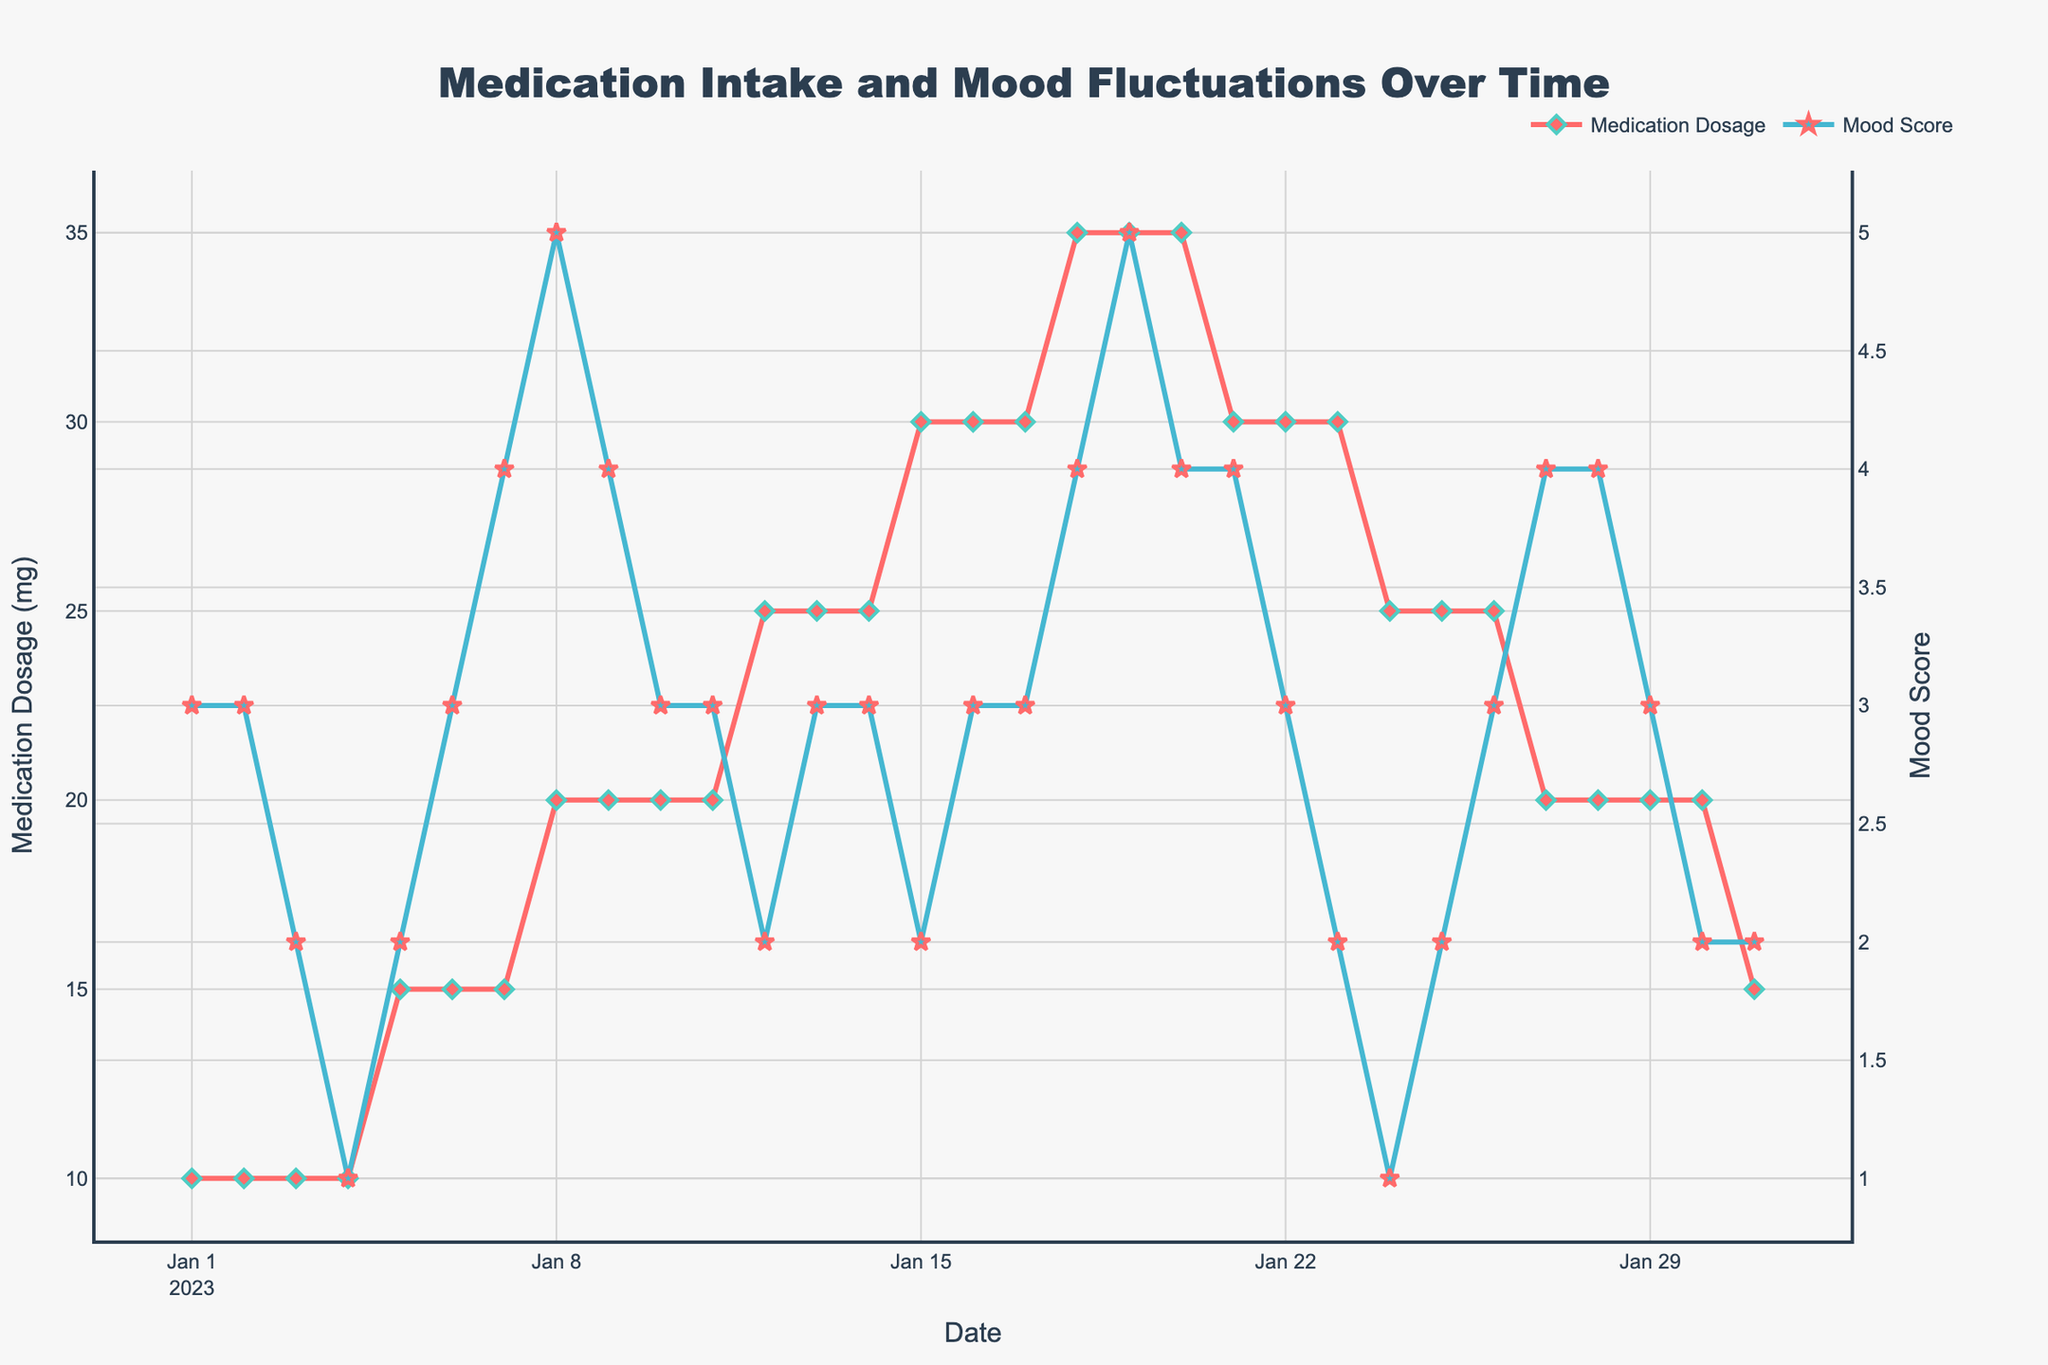what is the title of the figure? The title is displayed at the top center of the figure in a large font. It summarizes the content of the figure, indicating what the visualizations represent.
Answer: Medication Intake and Mood Fluctuations Over Time how many data points are there in total? Each date represents one data point, visible as markers on the plot. Both lines have data points marked by unique markers (diamonds and stars).
Answer: 31 what is the range of the mood score throughout the period? The Mood Score Y-axis shows values starting from the lowest point to the highest point during the plot period. By looking at the Mood Score trend line and markers, the minimum and maximum scores can be identified.
Answer: 1 to 5 what is the relationship between medication dosage and mood score on January 8th? January 8th marks a point on both Medication Dosage and Mood Score lines. By locating January 8th on the X-axis, you can observe the values on both Y-axes.
Answer: Medication Dosage: 20 mg, Mood Score: 5 what happened to the mood score when the medication dosage increased to 25 mg for the first time? Look at the date when the dosage first increased to 25 mg, check the Mood Score value before and after this date by following the mood score markers.
Answer: Dropped from 3 to 2 compare the trend of medication dosage and mood score from January 15th to 21st Observe the plot between January 15th and 21st. Track the changes in both Medication Dosage (left Y-axis) and Mood Score (right Y-axis) by noting the slopes and directions of the lines.
Answer: Medication Dosage increases to 35 mg and then drops to 30 mg. Mood Score rises from 2 to 4, then drops slightly what is the average medication dosage from Jan 10 to Jan 20? List the Medication Dosage values between Jan 10 and Jan 20, then calculate their mean by summing the values and dividing by the number of days. Values: 20, 20, 25, 25, 30, 30, 30, 35, 35, 35, 30. Sum: (20+20+25+25+30+30+30+35+35+35+30) = 315. Divide by the number of days: 315/11 = 28.6
Answer: 28.6 mg on which date did the mood score reach its lowest value? The lowest value on the Mood Score Y-axis is 1. Trace back to the X-axis to find the corresponding date. The point when Mood Score hits 1 is marked.
Answer: January 24 how do the trends of medication dosage and mood score change in the final week of January? Examine the plot from January 24th to January 31st. Follow the patterns of both lines, checking any increases or decreases in Medication Dosage and Mood Score.
Answer: Medication Dosage decreases from 25 to 15 mg. Mood Score fluctuates between 1 and 2 